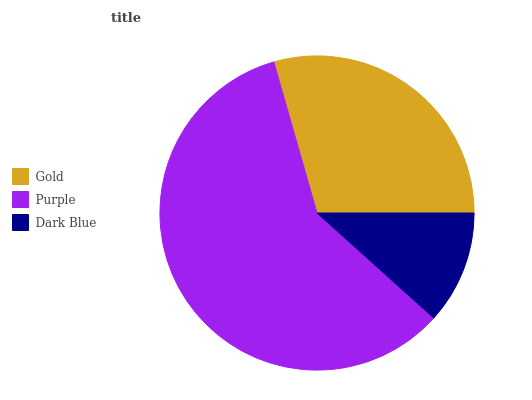Is Dark Blue the minimum?
Answer yes or no. Yes. Is Purple the maximum?
Answer yes or no. Yes. Is Purple the minimum?
Answer yes or no. No. Is Dark Blue the maximum?
Answer yes or no. No. Is Purple greater than Dark Blue?
Answer yes or no. Yes. Is Dark Blue less than Purple?
Answer yes or no. Yes. Is Dark Blue greater than Purple?
Answer yes or no. No. Is Purple less than Dark Blue?
Answer yes or no. No. Is Gold the high median?
Answer yes or no. Yes. Is Gold the low median?
Answer yes or no. Yes. Is Dark Blue the high median?
Answer yes or no. No. Is Purple the low median?
Answer yes or no. No. 